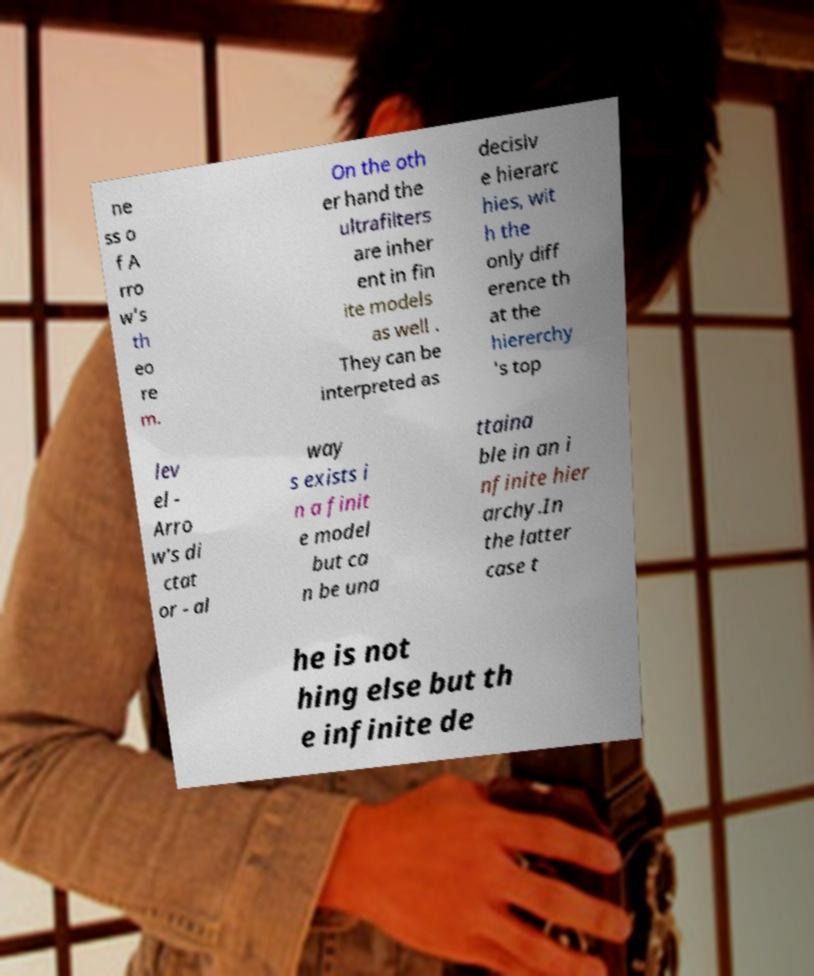What messages or text are displayed in this image? I need them in a readable, typed format. ne ss o f A rro w's th eo re m. On the oth er hand the ultrafilters are inher ent in fin ite models as well . They can be interpreted as decisiv e hierarc hies, wit h the only diff erence th at the hiererchy 's top lev el - Arro w's di ctat or - al way s exists i n a finit e model but ca n be una ttaina ble in an i nfinite hier archy.In the latter case t he is not hing else but th e infinite de 